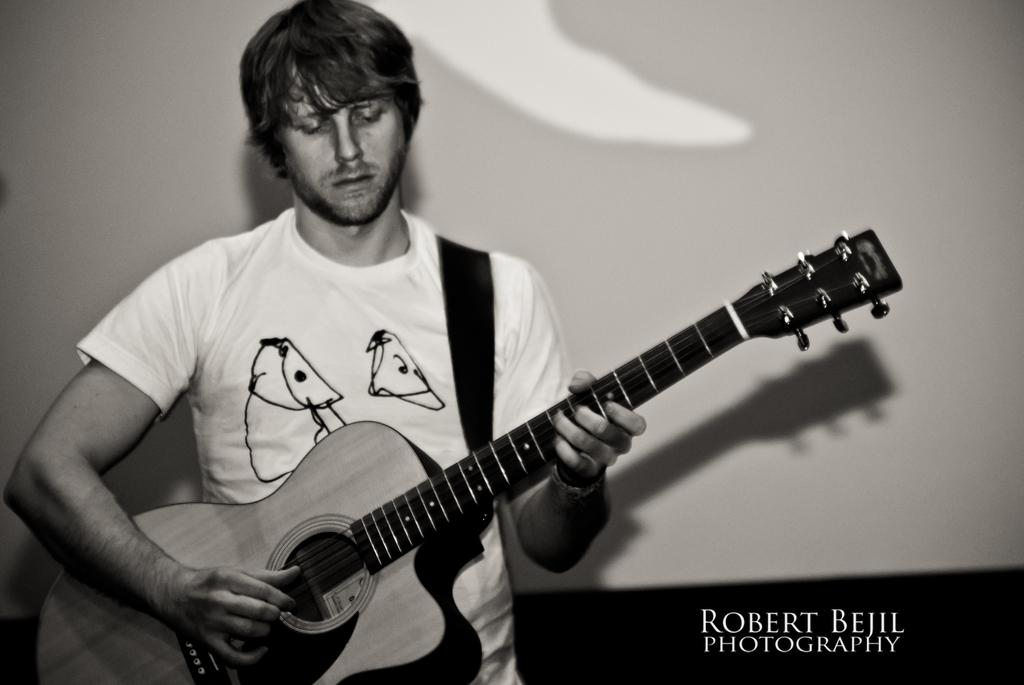What is the main subject of the image? The main subject of the image is a man. What is the man holding in the image? The man is holding a guitar in the image. What is the man doing with the guitar? The man is playing the guitar in the image. What type of reward is the man receiving for playing the guitar in the image? There is no indication in the image that the man is receiving a reward for playing the guitar. 